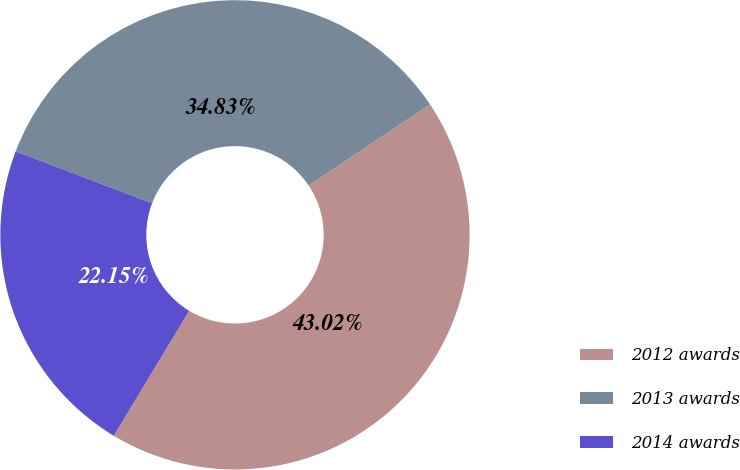Convert chart to OTSL. <chart><loc_0><loc_0><loc_500><loc_500><pie_chart><fcel>2012 awards<fcel>2013 awards<fcel>2014 awards<nl><fcel>43.02%<fcel>34.83%<fcel>22.15%<nl></chart> 